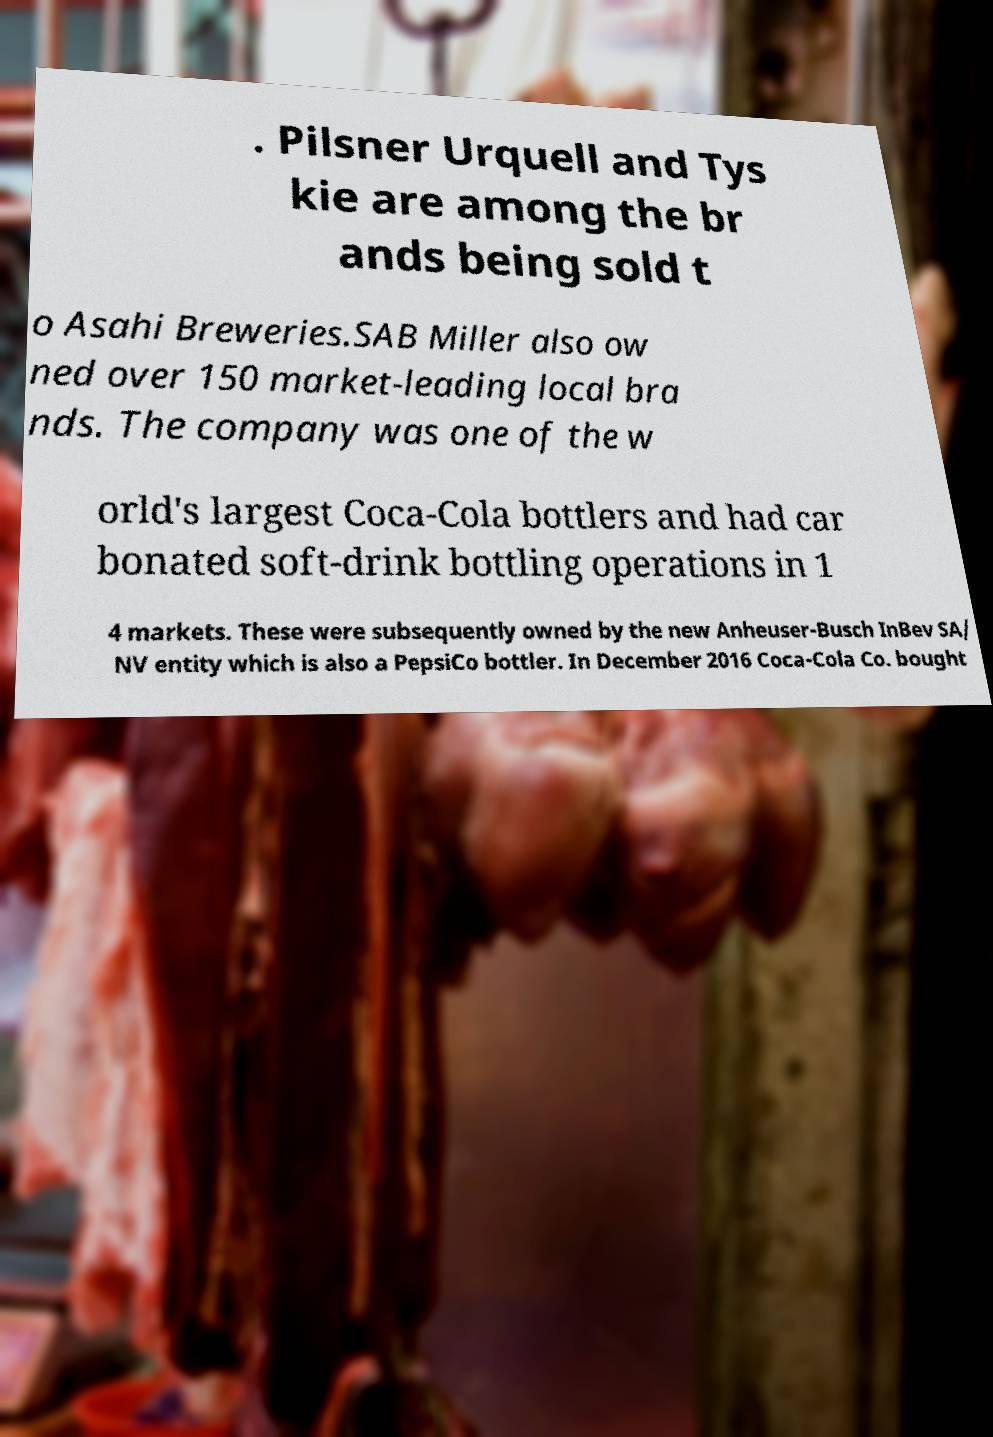There's text embedded in this image that I need extracted. Can you transcribe it verbatim? . Pilsner Urquell and Tys kie are among the br ands being sold t o Asahi Breweries.SAB Miller also ow ned over 150 market-leading local bra nds. The company was one of the w orld's largest Coca-Cola bottlers and had car bonated soft-drink bottling operations in 1 4 markets. These were subsequently owned by the new Anheuser-Busch InBev SA/ NV entity which is also a PepsiCo bottler. In December 2016 Coca-Cola Co. bought 